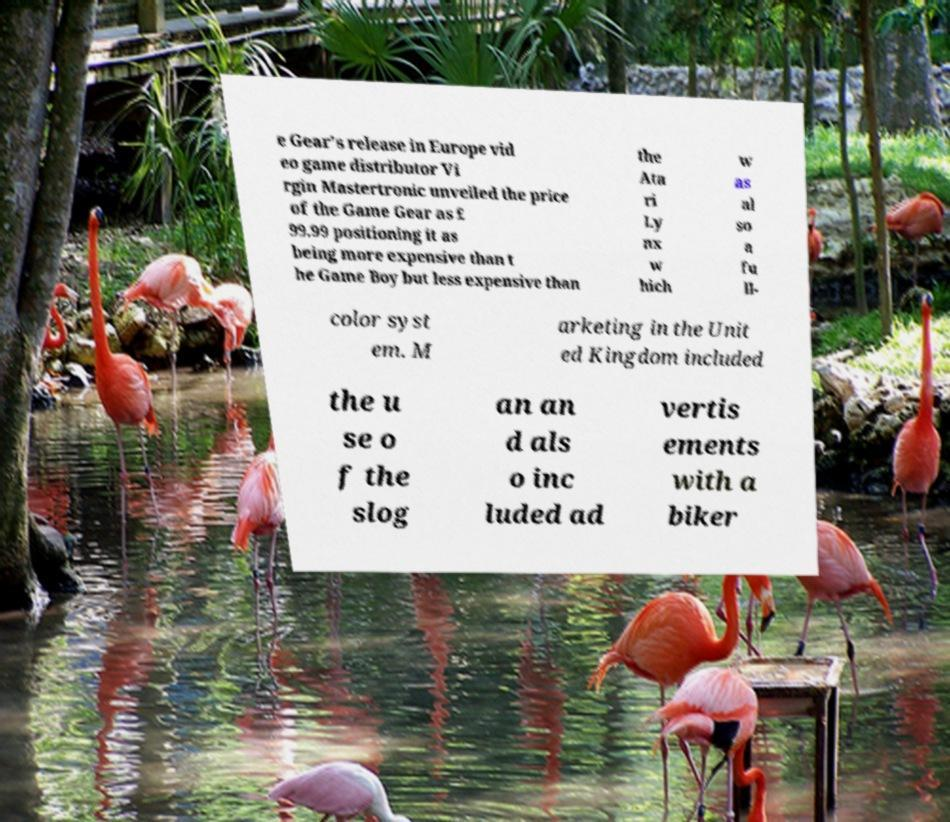Please read and relay the text visible in this image. What does it say? e Gear's release in Europe vid eo game distributor Vi rgin Mastertronic unveiled the price of the Game Gear as £ 99.99 positioning it as being more expensive than t he Game Boy but less expensive than the Ata ri Ly nx w hich w as al so a fu ll- color syst em. M arketing in the Unit ed Kingdom included the u se o f the slog an an d als o inc luded ad vertis ements with a biker 